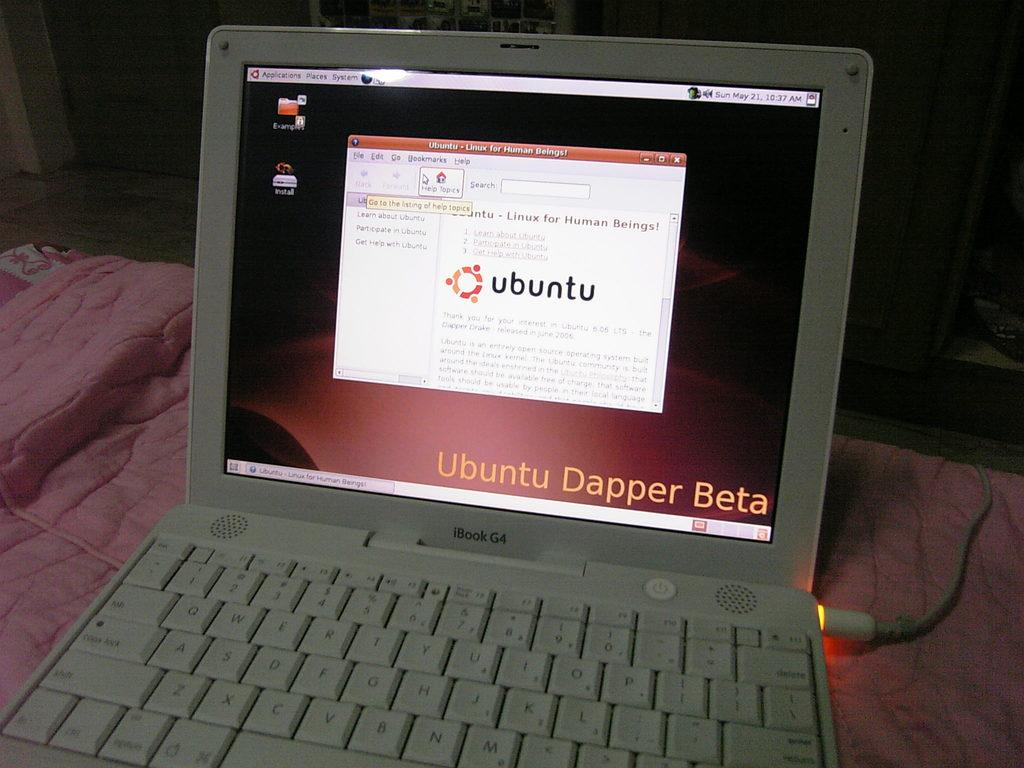<image>
Write a terse but informative summary of the picture. Open laptop with Ubuntu Dapper Beta on the screen. 